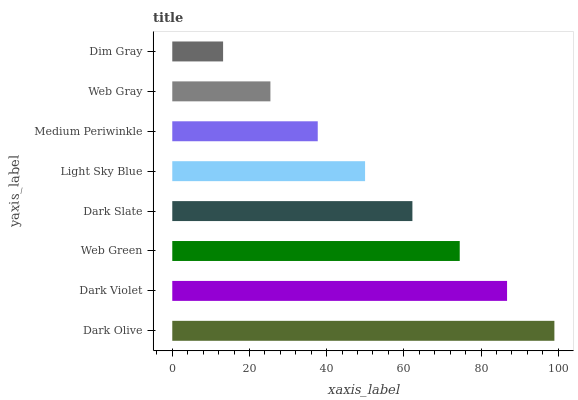Is Dim Gray the minimum?
Answer yes or no. Yes. Is Dark Olive the maximum?
Answer yes or no. Yes. Is Dark Violet the minimum?
Answer yes or no. No. Is Dark Violet the maximum?
Answer yes or no. No. Is Dark Olive greater than Dark Violet?
Answer yes or no. Yes. Is Dark Violet less than Dark Olive?
Answer yes or no. Yes. Is Dark Violet greater than Dark Olive?
Answer yes or no. No. Is Dark Olive less than Dark Violet?
Answer yes or no. No. Is Dark Slate the high median?
Answer yes or no. Yes. Is Light Sky Blue the low median?
Answer yes or no. Yes. Is Dim Gray the high median?
Answer yes or no. No. Is Dark Violet the low median?
Answer yes or no. No. 